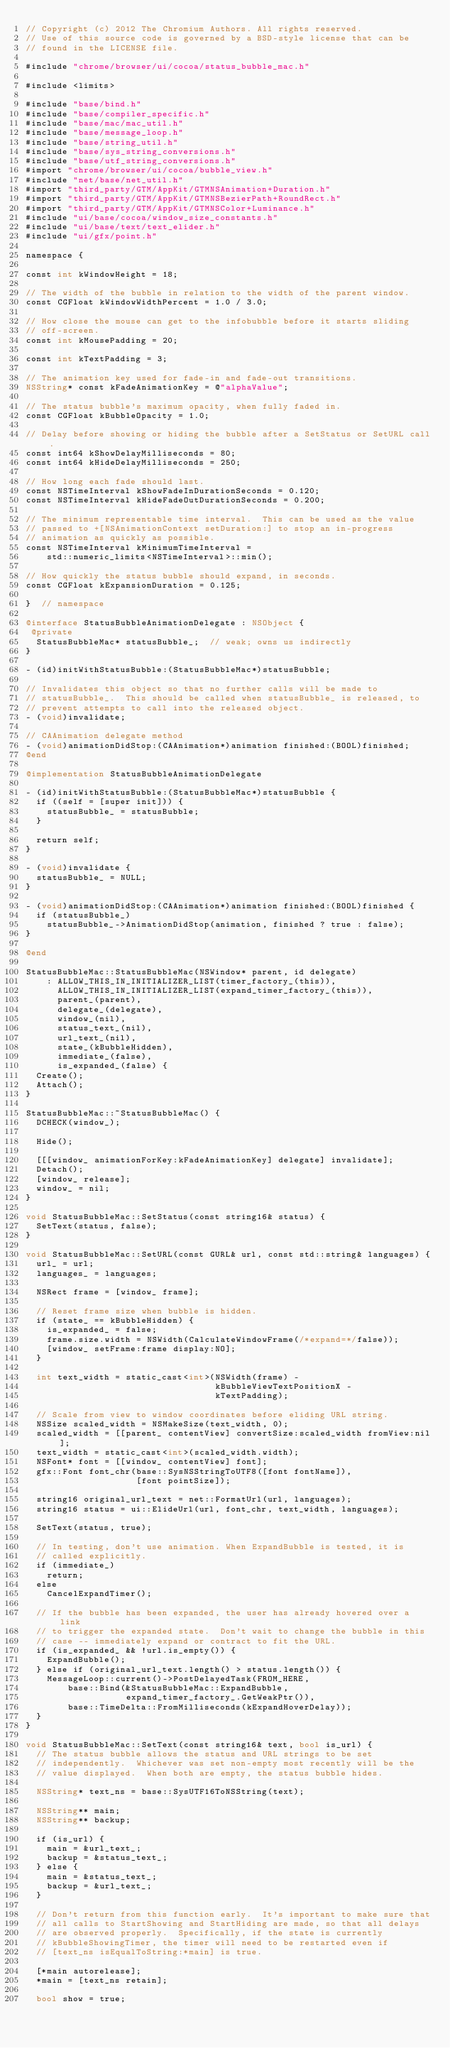Convert code to text. <code><loc_0><loc_0><loc_500><loc_500><_ObjectiveC_>// Copyright (c) 2012 The Chromium Authors. All rights reserved.
// Use of this source code is governed by a BSD-style license that can be
// found in the LICENSE file.

#include "chrome/browser/ui/cocoa/status_bubble_mac.h"

#include <limits>

#include "base/bind.h"
#include "base/compiler_specific.h"
#include "base/mac/mac_util.h"
#include "base/message_loop.h"
#include "base/string_util.h"
#include "base/sys_string_conversions.h"
#include "base/utf_string_conversions.h"
#import "chrome/browser/ui/cocoa/bubble_view.h"
#include "net/base/net_util.h"
#import "third_party/GTM/AppKit/GTMNSAnimation+Duration.h"
#import "third_party/GTM/AppKit/GTMNSBezierPath+RoundRect.h"
#import "third_party/GTM/AppKit/GTMNSColor+Luminance.h"
#include "ui/base/cocoa/window_size_constants.h"
#include "ui/base/text/text_elider.h"
#include "ui/gfx/point.h"

namespace {

const int kWindowHeight = 18;

// The width of the bubble in relation to the width of the parent window.
const CGFloat kWindowWidthPercent = 1.0 / 3.0;

// How close the mouse can get to the infobubble before it starts sliding
// off-screen.
const int kMousePadding = 20;

const int kTextPadding = 3;

// The animation key used for fade-in and fade-out transitions.
NSString* const kFadeAnimationKey = @"alphaValue";

// The status bubble's maximum opacity, when fully faded in.
const CGFloat kBubbleOpacity = 1.0;

// Delay before showing or hiding the bubble after a SetStatus or SetURL call.
const int64 kShowDelayMilliseconds = 80;
const int64 kHideDelayMilliseconds = 250;

// How long each fade should last.
const NSTimeInterval kShowFadeInDurationSeconds = 0.120;
const NSTimeInterval kHideFadeOutDurationSeconds = 0.200;

// The minimum representable time interval.  This can be used as the value
// passed to +[NSAnimationContext setDuration:] to stop an in-progress
// animation as quickly as possible.
const NSTimeInterval kMinimumTimeInterval =
    std::numeric_limits<NSTimeInterval>::min();

// How quickly the status bubble should expand, in seconds.
const CGFloat kExpansionDuration = 0.125;

}  // namespace

@interface StatusBubbleAnimationDelegate : NSObject {
 @private
  StatusBubbleMac* statusBubble_;  // weak; owns us indirectly
}

- (id)initWithStatusBubble:(StatusBubbleMac*)statusBubble;

// Invalidates this object so that no further calls will be made to
// statusBubble_.  This should be called when statusBubble_ is released, to
// prevent attempts to call into the released object.
- (void)invalidate;

// CAAnimation delegate method
- (void)animationDidStop:(CAAnimation*)animation finished:(BOOL)finished;
@end

@implementation StatusBubbleAnimationDelegate

- (id)initWithStatusBubble:(StatusBubbleMac*)statusBubble {
  if ((self = [super init])) {
    statusBubble_ = statusBubble;
  }

  return self;
}

- (void)invalidate {
  statusBubble_ = NULL;
}

- (void)animationDidStop:(CAAnimation*)animation finished:(BOOL)finished {
  if (statusBubble_)
    statusBubble_->AnimationDidStop(animation, finished ? true : false);
}

@end

StatusBubbleMac::StatusBubbleMac(NSWindow* parent, id delegate)
    : ALLOW_THIS_IN_INITIALIZER_LIST(timer_factory_(this)),
      ALLOW_THIS_IN_INITIALIZER_LIST(expand_timer_factory_(this)),
      parent_(parent),
      delegate_(delegate),
      window_(nil),
      status_text_(nil),
      url_text_(nil),
      state_(kBubbleHidden),
      immediate_(false),
      is_expanded_(false) {
  Create();
  Attach();
}

StatusBubbleMac::~StatusBubbleMac() {
  DCHECK(window_);

  Hide();

  [[[window_ animationForKey:kFadeAnimationKey] delegate] invalidate];
  Detach();
  [window_ release];
  window_ = nil;
}

void StatusBubbleMac::SetStatus(const string16& status) {
  SetText(status, false);
}

void StatusBubbleMac::SetURL(const GURL& url, const std::string& languages) {
  url_ = url;
  languages_ = languages;

  NSRect frame = [window_ frame];

  // Reset frame size when bubble is hidden.
  if (state_ == kBubbleHidden) {
    is_expanded_ = false;
    frame.size.width = NSWidth(CalculateWindowFrame(/*expand=*/false));
    [window_ setFrame:frame display:NO];
  }

  int text_width = static_cast<int>(NSWidth(frame) -
                                    kBubbleViewTextPositionX -
                                    kTextPadding);

  // Scale from view to window coordinates before eliding URL string.
  NSSize scaled_width = NSMakeSize(text_width, 0);
  scaled_width = [[parent_ contentView] convertSize:scaled_width fromView:nil];
  text_width = static_cast<int>(scaled_width.width);
  NSFont* font = [[window_ contentView] font];
  gfx::Font font_chr(base::SysNSStringToUTF8([font fontName]),
                     [font pointSize]);

  string16 original_url_text = net::FormatUrl(url, languages);
  string16 status = ui::ElideUrl(url, font_chr, text_width, languages);

  SetText(status, true);

  // In testing, don't use animation. When ExpandBubble is tested, it is
  // called explicitly.
  if (immediate_)
    return;
  else
    CancelExpandTimer();

  // If the bubble has been expanded, the user has already hovered over a link
  // to trigger the expanded state.  Don't wait to change the bubble in this
  // case -- immediately expand or contract to fit the URL.
  if (is_expanded_ && !url.is_empty()) {
    ExpandBubble();
  } else if (original_url_text.length() > status.length()) {
    MessageLoop::current()->PostDelayedTask(FROM_HERE,
        base::Bind(&StatusBubbleMac::ExpandBubble,
                   expand_timer_factory_.GetWeakPtr()),
        base::TimeDelta::FromMilliseconds(kExpandHoverDelay));
  }
}

void StatusBubbleMac::SetText(const string16& text, bool is_url) {
  // The status bubble allows the status and URL strings to be set
  // independently.  Whichever was set non-empty most recently will be the
  // value displayed.  When both are empty, the status bubble hides.

  NSString* text_ns = base::SysUTF16ToNSString(text);

  NSString** main;
  NSString** backup;

  if (is_url) {
    main = &url_text_;
    backup = &status_text_;
  } else {
    main = &status_text_;
    backup = &url_text_;
  }

  // Don't return from this function early.  It's important to make sure that
  // all calls to StartShowing and StartHiding are made, so that all delays
  // are observed properly.  Specifically, if the state is currently
  // kBubbleShowingTimer, the timer will need to be restarted even if
  // [text_ns isEqualToString:*main] is true.

  [*main autorelease];
  *main = [text_ns retain];

  bool show = true;</code> 